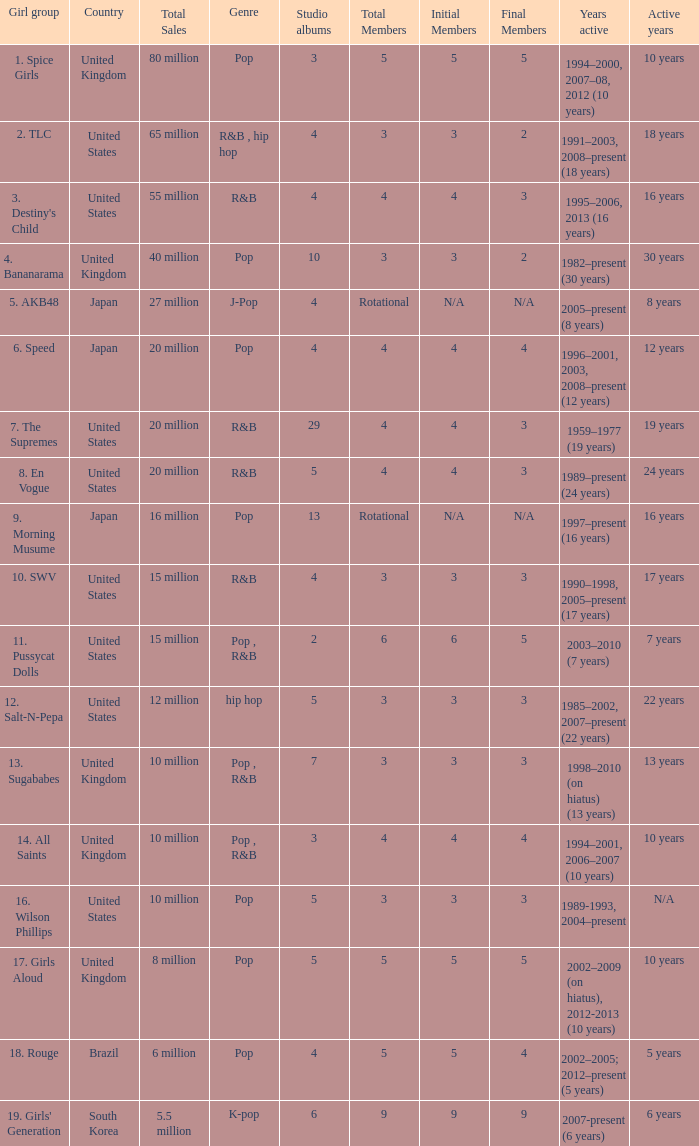How many people were part of the group responsible for selling 65 million albums and singles? 3 → 2. 